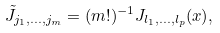Convert formula to latex. <formula><loc_0><loc_0><loc_500><loc_500>\tilde { J } _ { j _ { 1 } , \dots , j _ { m } } = ( m ! ) ^ { - 1 } J _ { l _ { 1 } , \dots , l _ { p } } ( x ) ,</formula> 